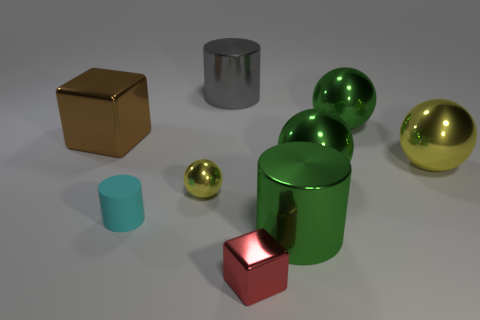What is the color of the small thing that is the same shape as the big yellow thing?
Your answer should be very brief. Yellow. Is there another metal sphere that has the same color as the small sphere?
Your response must be concise. Yes. There is a big object that is the same color as the tiny shiny ball; what is its shape?
Ensure brevity in your answer.  Sphere. There is a tiny metallic object that is on the left side of the small red object; does it have the same shape as the big yellow metal object?
Your answer should be compact. Yes. Are there any red things of the same shape as the brown metallic thing?
Provide a succinct answer. Yes. What number of objects are either small gray metal cylinders or spheres?
Provide a succinct answer. 4. Is there a cyan metal cube?
Offer a terse response. No. Is the number of green metallic cylinders less than the number of small green metal blocks?
Offer a very short reply. No. Is there a yellow metallic sphere that has the same size as the cyan matte thing?
Keep it short and to the point. Yes. Does the tiny cyan object have the same shape as the tiny object to the right of the small yellow thing?
Ensure brevity in your answer.  No. 